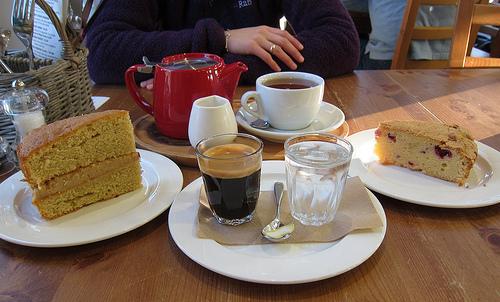<image>
Can you confirm if the glass is on the plate? Yes. Looking at the image, I can see the glass is positioned on top of the plate, with the plate providing support. Is the cake in the water? No. The cake is not contained within the water. These objects have a different spatial relationship. Is there a glass above the plate? No. The glass is not positioned above the plate. The vertical arrangement shows a different relationship. 